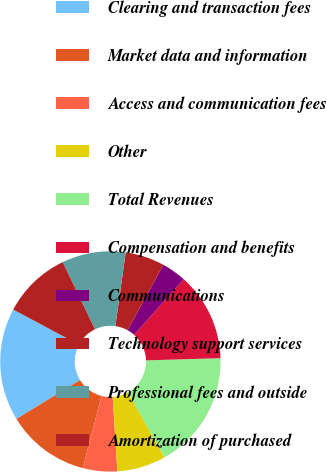Convert chart to OTSL. <chart><loc_0><loc_0><loc_500><loc_500><pie_chart><fcel>Clearing and transaction fees<fcel>Market data and information<fcel>Access and communication fees<fcel>Other<fcel>Total Revenues<fcel>Compensation and benefits<fcel>Communications<fcel>Technology support services<fcel>Professional fees and outside<fcel>Amortization of purchased<nl><fcel>16.55%<fcel>12.23%<fcel>5.04%<fcel>7.19%<fcel>17.27%<fcel>12.95%<fcel>3.6%<fcel>5.76%<fcel>9.35%<fcel>10.07%<nl></chart> 